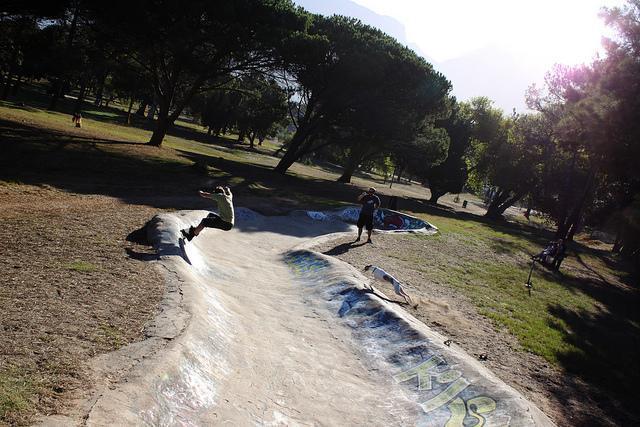Which person could be attacked by the dog first?
From the following set of four choices, select the accurate answer to respond to the question.
Options: Black shirt, green shirt, red shirt, white shirt. Green shirt. 